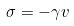<formula> <loc_0><loc_0><loc_500><loc_500>\sigma = - \gamma v</formula> 